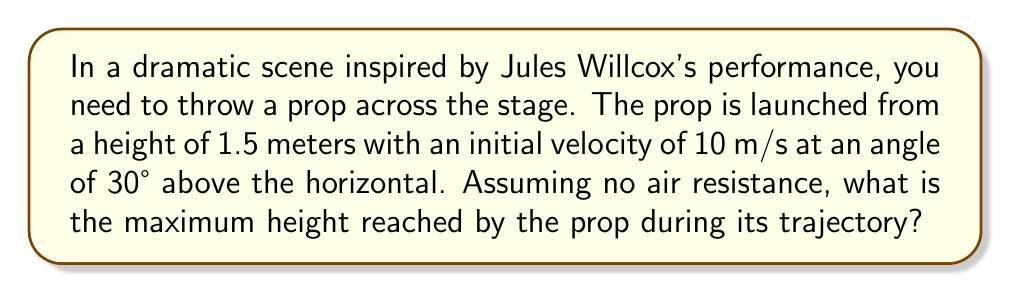Can you solve this math problem? To solve this problem, we'll use the equations of motion for projectile motion. Let's break it down step-by-step:

1) First, we need to find the vertical component of the initial velocity:
   $v_{y0} = v_0 \sin \theta = 10 \cdot \sin 30° = 5$ m/s

2) The maximum height is reached when the vertical velocity becomes zero. We can use the equation:
   $v_y^2 = v_{y0}^2 + 2a(y - y_0)$

   Where:
   $v_y = 0$ (at the highest point)
   $v_{y0} = 5$ m/s
   $a = -g = -9.8$ m/s²
   $y_0 = 1.5$ m (initial height)

3) Substituting these values:
   $0^2 = 5^2 + 2(-9.8)(y - 1.5)$

4) Solving for y:
   $0 = 25 - 19.6(y - 1.5)$
   $19.6y - 29.4 = 25$
   $19.6y = 54.4$
   $y = 2.776$ m

5) To find the maximum height reached, we subtract the initial height:
   $h_{max} = 2.776 - 1.5 = 1.276$ m

Therefore, the prop reaches a maximum height of 1.276 meters above its starting point.
Answer: 1.28 m 